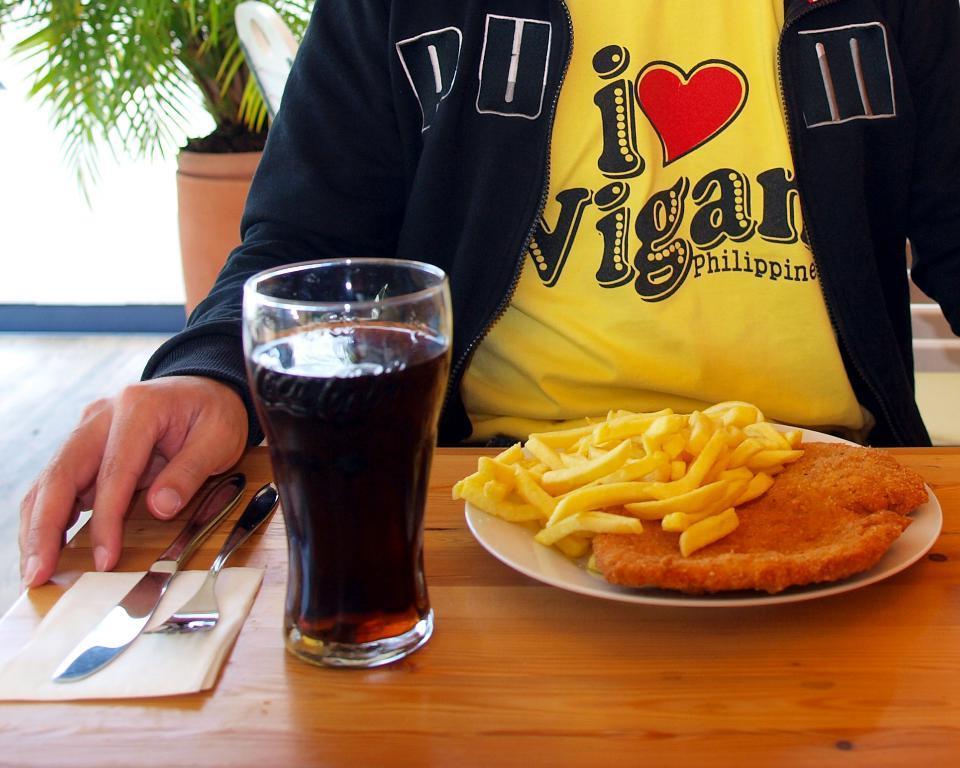In one or two sentences, can you explain what this image depicts? In this image I can see the person sitting in-front of the table. On the table I can see the glass with drink, plate with food, knife, fork and the tissue paper. I can see the person is wearing the yellow and navy blue color dress. To the left I can see the flower pot. 